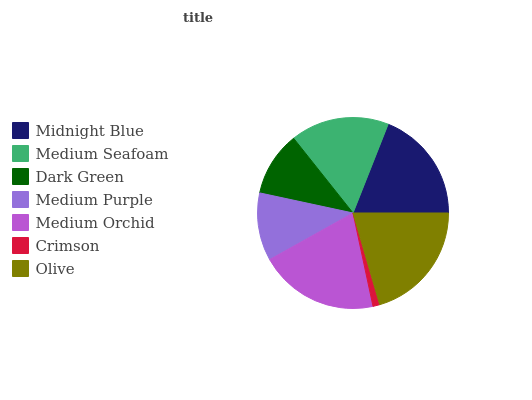Is Crimson the minimum?
Answer yes or no. Yes. Is Olive the maximum?
Answer yes or no. Yes. Is Medium Seafoam the minimum?
Answer yes or no. No. Is Medium Seafoam the maximum?
Answer yes or no. No. Is Midnight Blue greater than Medium Seafoam?
Answer yes or no. Yes. Is Medium Seafoam less than Midnight Blue?
Answer yes or no. Yes. Is Medium Seafoam greater than Midnight Blue?
Answer yes or no. No. Is Midnight Blue less than Medium Seafoam?
Answer yes or no. No. Is Medium Seafoam the high median?
Answer yes or no. Yes. Is Medium Seafoam the low median?
Answer yes or no. Yes. Is Olive the high median?
Answer yes or no. No. Is Midnight Blue the low median?
Answer yes or no. No. 